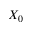<formula> <loc_0><loc_0><loc_500><loc_500>X _ { 0 }</formula> 